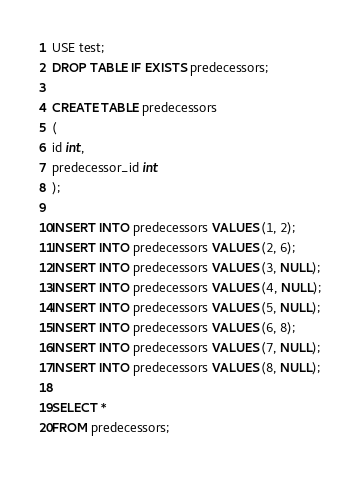Convert code to text. <code><loc_0><loc_0><loc_500><loc_500><_SQL_>USE test;
DROP TABLE IF EXISTS predecessors;

CREATE TABLE predecessors
(
id int,
predecessor_id int
);

INSERT INTO predecessors VALUES (1, 2);
INSERT INTO predecessors VALUES (2, 6);
INSERT INTO predecessors VALUES (3, NULL);
INSERT INTO predecessors VALUES (4, NULL);
INSERT INTO predecessors VALUES (5, NULL);
INSERT INTO predecessors VALUES (6, 8);
INSERT INTO predecessors VALUES (7, NULL);
INSERT INTO predecessors VALUES (8, NULL);

SELECT *
FROM predecessors;
</code> 